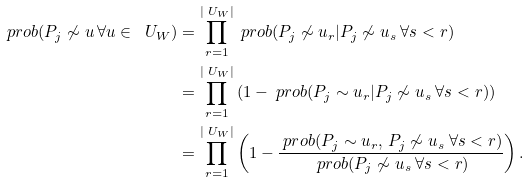<formula> <loc_0><loc_0><loc_500><loc_500>\ p r o b ( P _ { j } \not \sim u \, \forall u \in \ U _ { W } ) & = \prod _ { r = 1 } ^ { | \ U _ { W } | } \ p r o b ( P _ { j } \not \sim u _ { r } | P _ { j } \not \sim u _ { s } \ \forall s < r ) \\ & = \prod _ { r = 1 } ^ { | \ U _ { W } | } \left ( 1 - \ p r o b ( P _ { j } \sim u _ { r } | P _ { j } \not \sim u _ { s } \ \forall s < r ) \right ) \\ & = \prod _ { r = 1 } ^ { | \ U _ { W } | } \left ( 1 - \frac { \ p r o b ( P _ { j } \sim u _ { r } , \, P _ { j } \not \sim u _ { s } \ \forall s < r ) } { \ p r o b ( P _ { j } \not \sim u _ { s } \ \forall s < r ) } \right ) .</formula> 